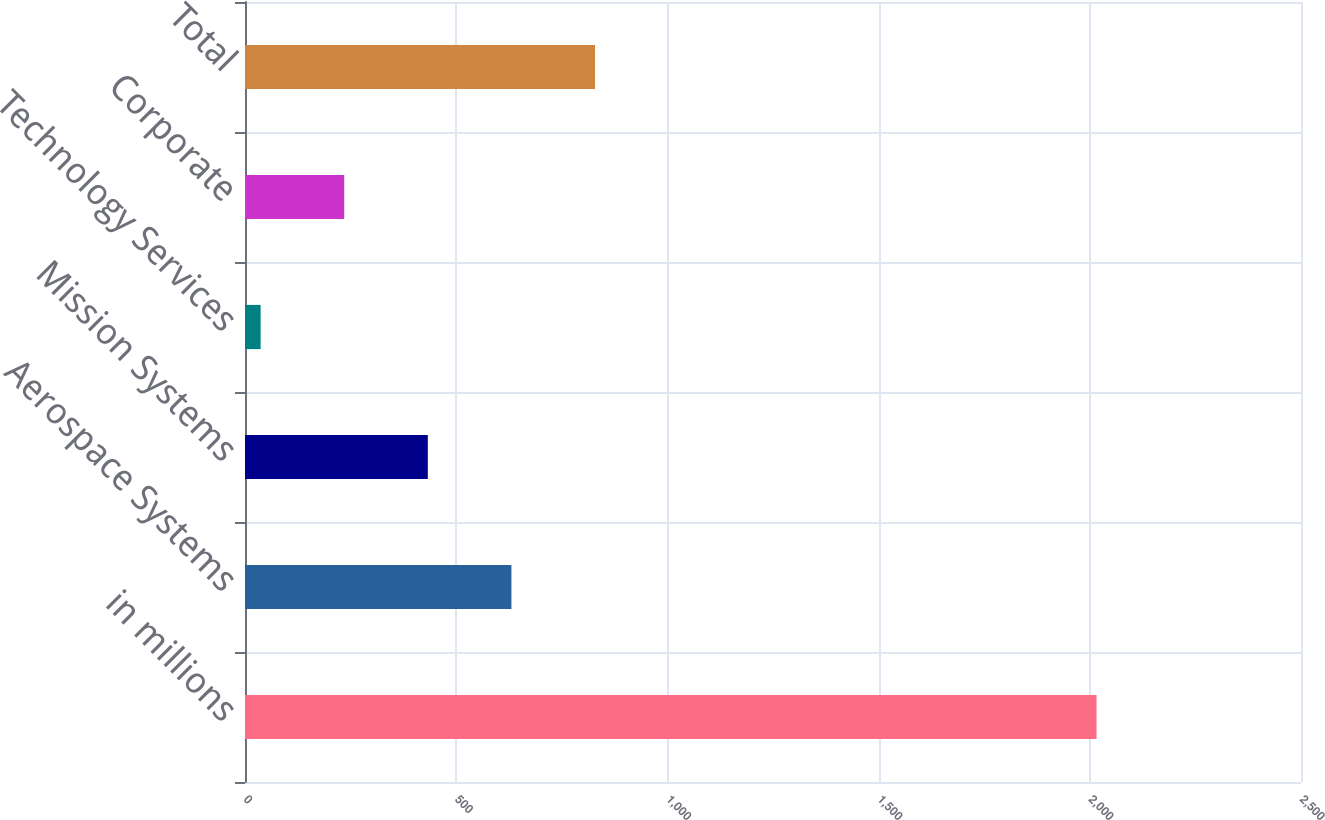Convert chart. <chart><loc_0><loc_0><loc_500><loc_500><bar_chart><fcel>in millions<fcel>Aerospace Systems<fcel>Mission Systems<fcel>Technology Services<fcel>Corporate<fcel>Total<nl><fcel>2016<fcel>630.7<fcel>432.8<fcel>37<fcel>234.9<fcel>828.6<nl></chart> 